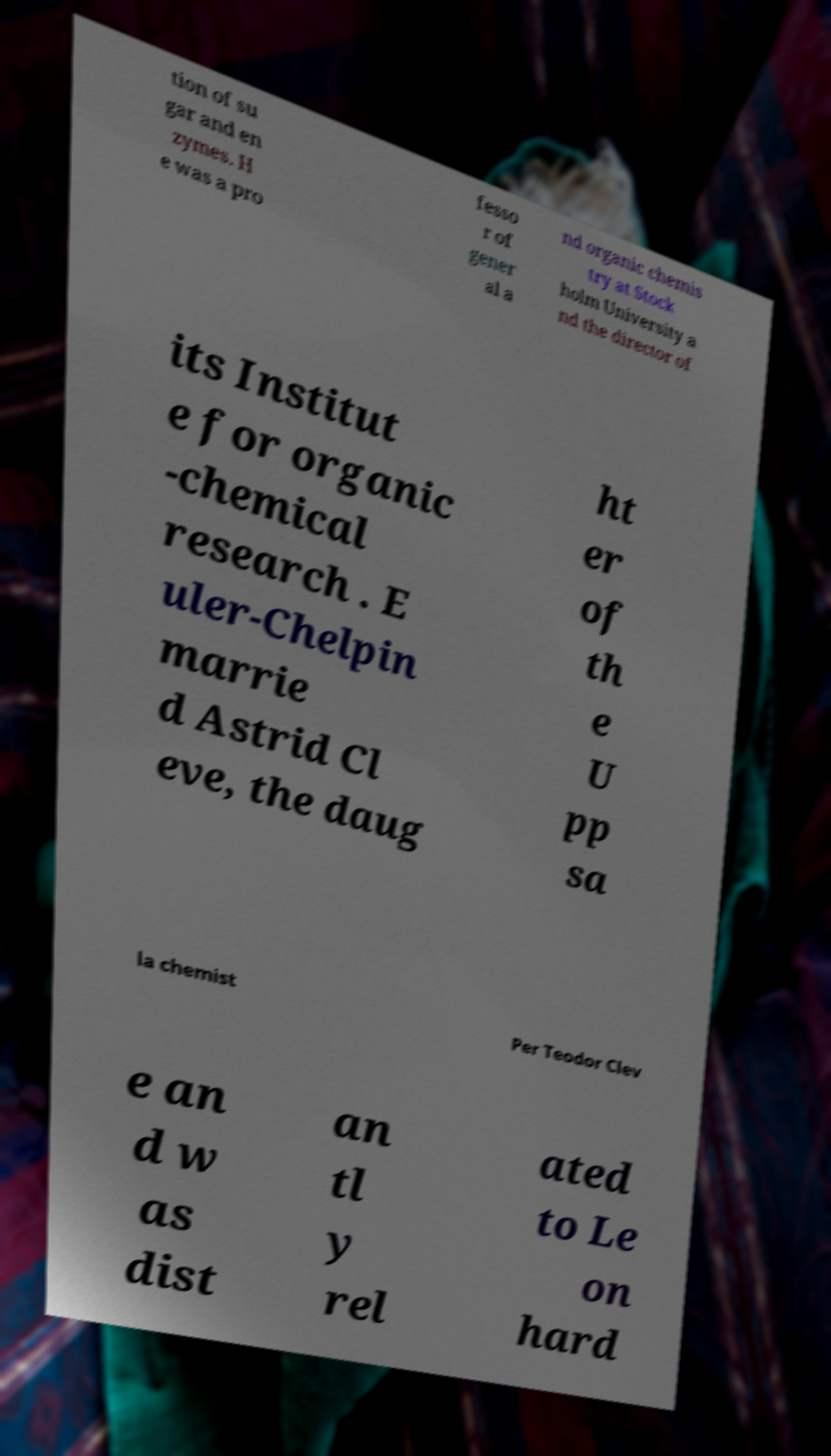What messages or text are displayed in this image? I need them in a readable, typed format. tion of su gar and en zymes. H e was a pro fesso r of gener al a nd organic chemis try at Stock holm University a nd the director of its Institut e for organic -chemical research . E uler-Chelpin marrie d Astrid Cl eve, the daug ht er of th e U pp sa la chemist Per Teodor Clev e an d w as dist an tl y rel ated to Le on hard 